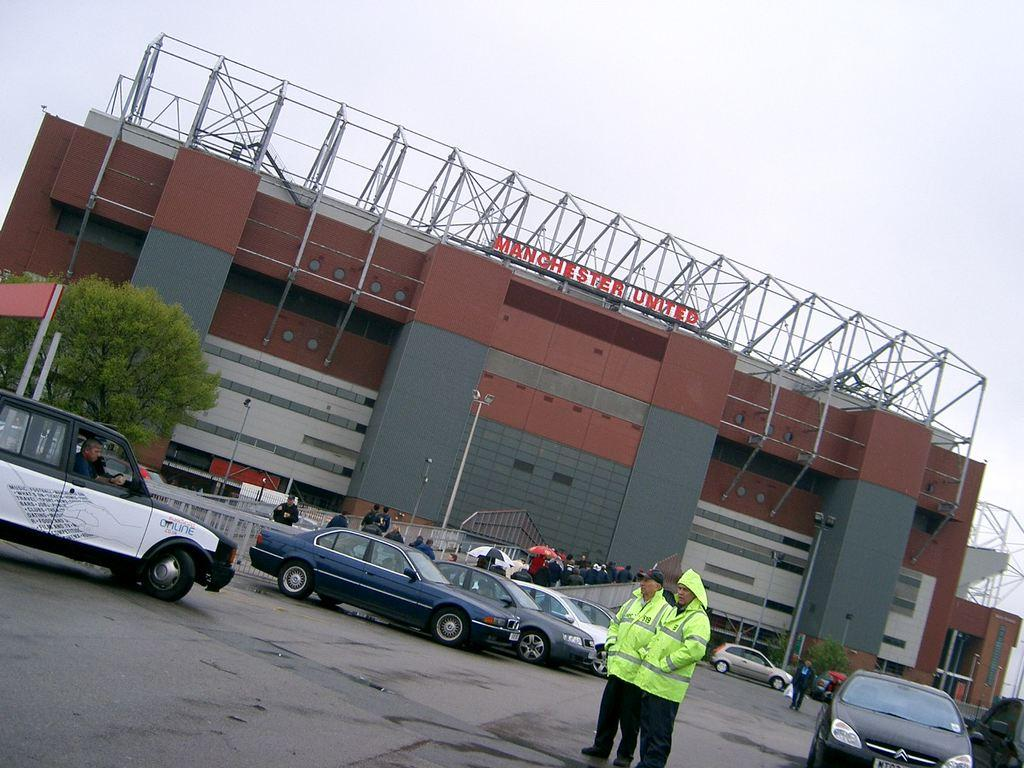How many people are present in the image? There are two men standing in the image. What are the men wearing? The men are wearing jackets. What can be seen on the road in the image? There are cars parked on the road in the image. What is visible in the background of the image? There are buildings and trees visible in the background of the image. What type of hospital can be seen in the image? There is no hospital present in the image. How does the wind affect the adjustment of the trees in the image? The image does not provide information about the wind or the adjustment of the trees. 